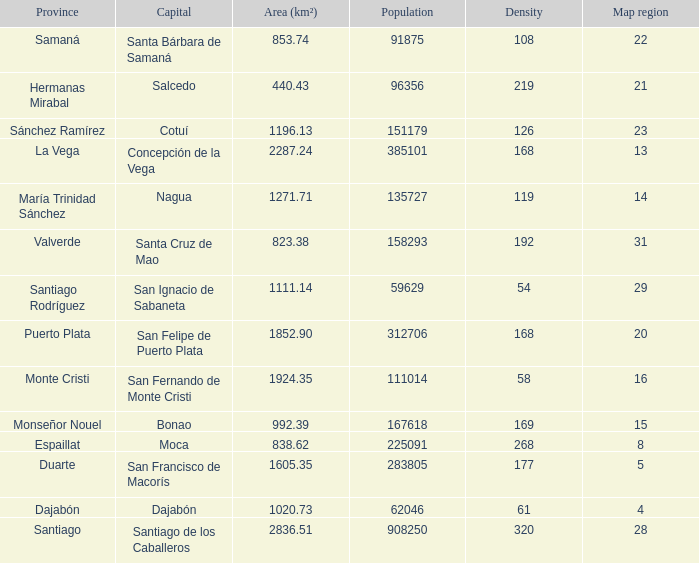When province is monseñor nouel, what is the area (km²)? 992.39. 